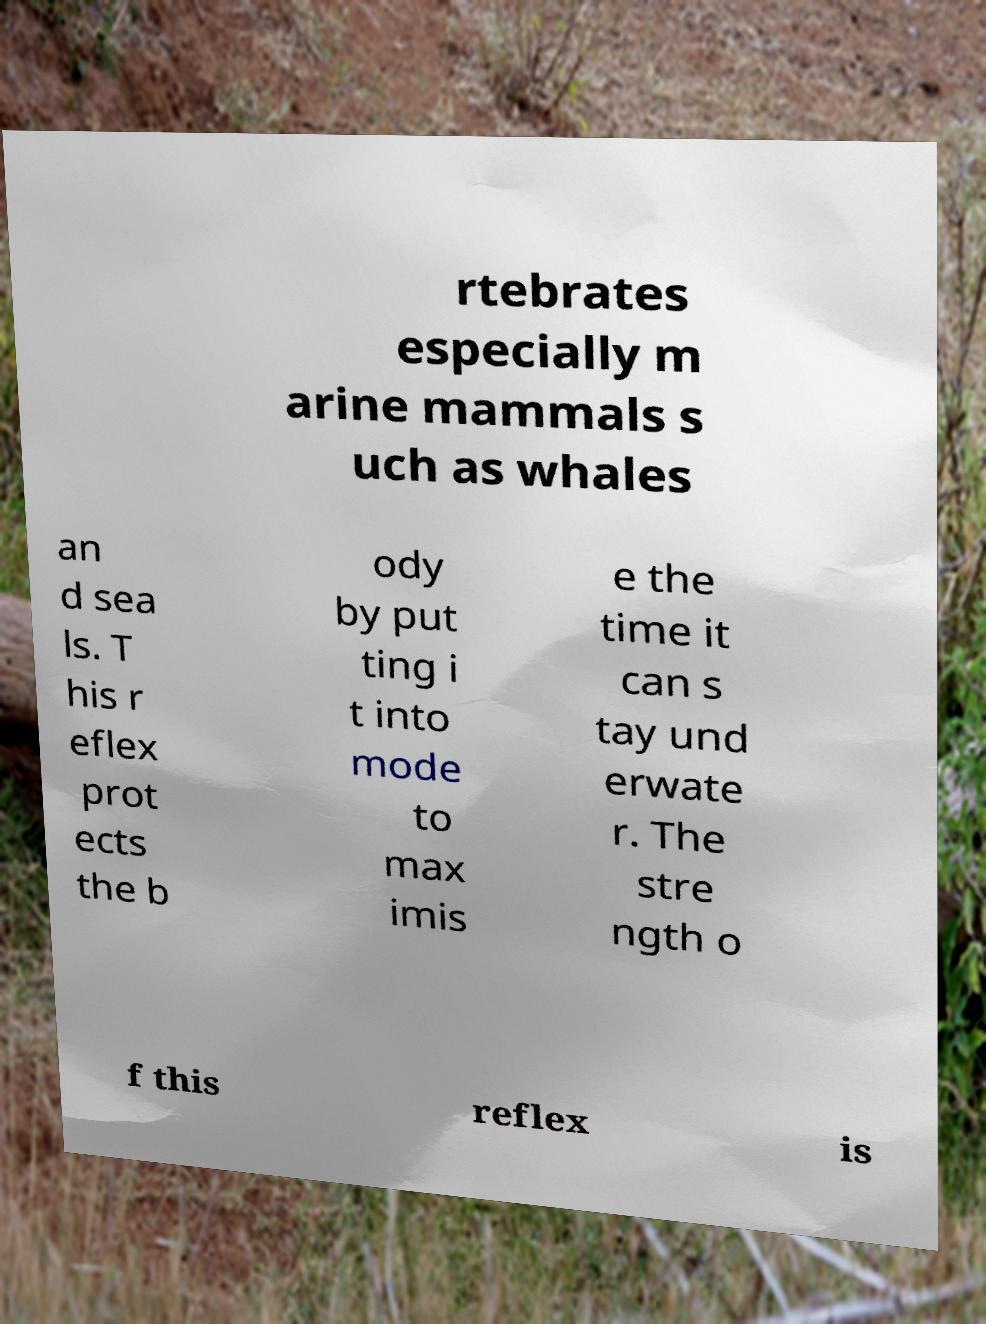Please identify and transcribe the text found in this image. rtebrates especially m arine mammals s uch as whales an d sea ls. T his r eflex prot ects the b ody by put ting i t into mode to max imis e the time it can s tay und erwate r. The stre ngth o f this reflex is 